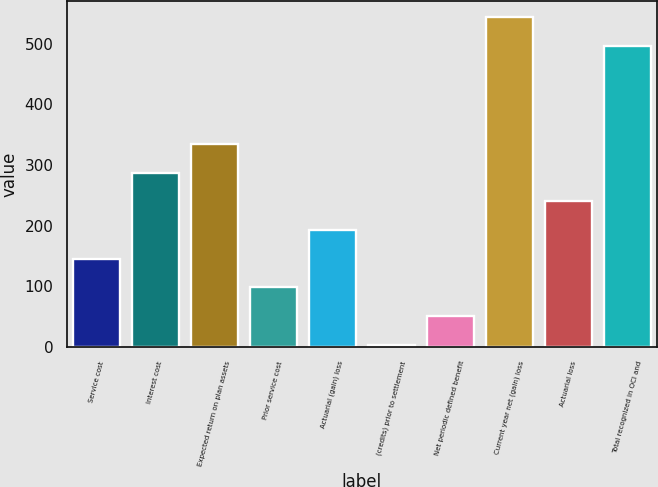Convert chart to OTSL. <chart><loc_0><loc_0><loc_500><loc_500><bar_chart><fcel>Service cost<fcel>Interest cost<fcel>Expected return on plan assets<fcel>Prior service cost<fcel>Actuarial (gain) loss<fcel>(credits) prior to settlement<fcel>Net periodic defined benefit<fcel>Current year net (gain) loss<fcel>Actuarial loss<fcel>Total recognized in OCI and<nl><fcel>145.6<fcel>287.2<fcel>334.4<fcel>98.4<fcel>192.8<fcel>4<fcel>51.2<fcel>543.4<fcel>240<fcel>496.2<nl></chart> 